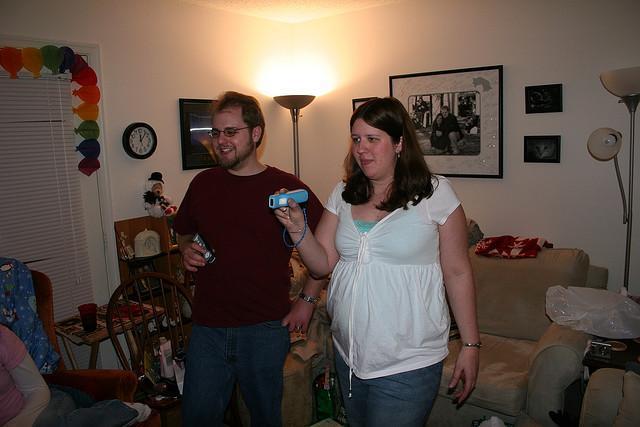What session of the day is it?
Indicate the correct response and explain using: 'Answer: answer
Rationale: rationale.'
Options: Midnight, evening, morning, afternoon. Answer: midnight.
Rationale: It's midnight out. 